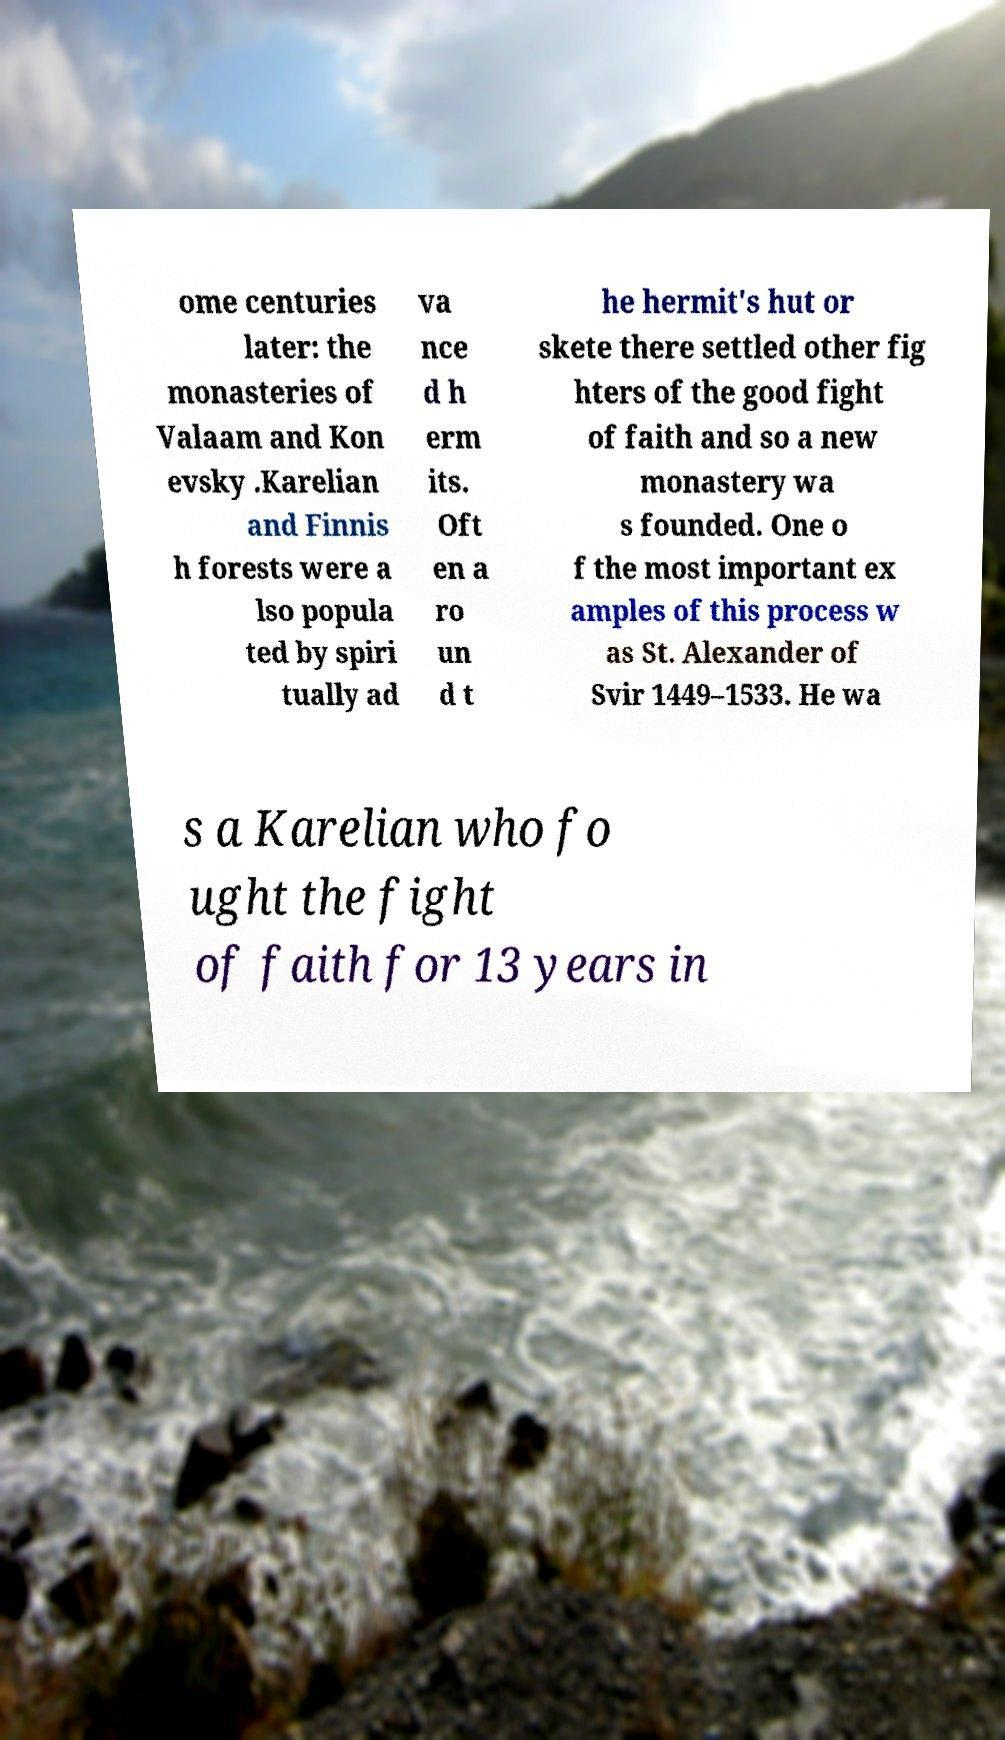What messages or text are displayed in this image? I need them in a readable, typed format. ome centuries later: the monasteries of Valaam and Kon evsky .Karelian and Finnis h forests were a lso popula ted by spiri tually ad va nce d h erm its. Oft en a ro un d t he hermit's hut or skete there settled other fig hters of the good fight of faith and so a new monastery wa s founded. One o f the most important ex amples of this process w as St. Alexander of Svir 1449–1533. He wa s a Karelian who fo ught the fight of faith for 13 years in 